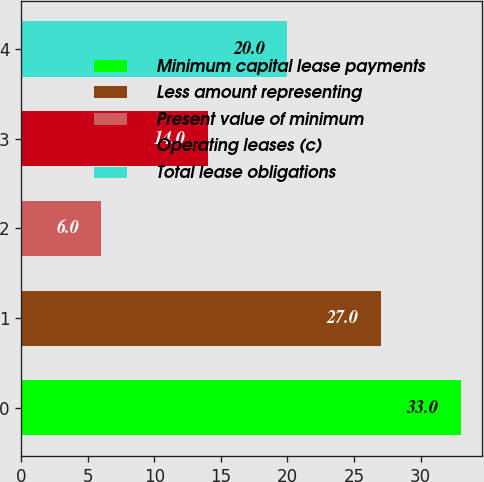Convert chart to OTSL. <chart><loc_0><loc_0><loc_500><loc_500><bar_chart><fcel>Minimum capital lease payments<fcel>Less amount representing<fcel>Present value of minimum<fcel>Operating leases (c)<fcel>Total lease obligations<nl><fcel>33<fcel>27<fcel>6<fcel>14<fcel>20<nl></chart> 